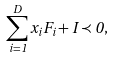Convert formula to latex. <formula><loc_0><loc_0><loc_500><loc_500>\sum _ { i = 1 } ^ { D } x _ { i } F _ { i } + I \prec 0 ,</formula> 